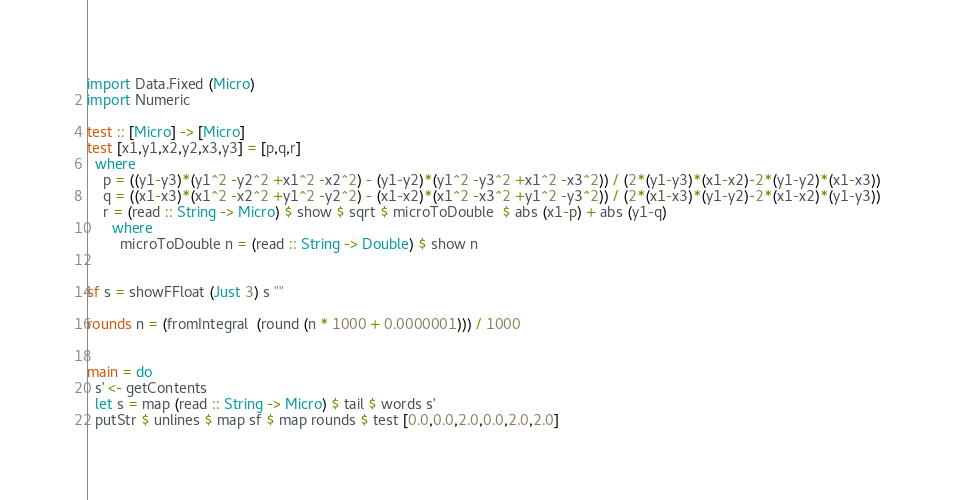<code> <loc_0><loc_0><loc_500><loc_500><_Haskell_>import Data.Fixed (Micro)
import Numeric

test :: [Micro] -> [Micro]
test [x1,y1,x2,y2,x3,y3] = [p,q,r]
  where
    p = ((y1-y3)*(y1^2 -y2^2 +x1^2 -x2^2) - (y1-y2)*(y1^2 -y3^2 +x1^2 -x3^2)) / (2*(y1-y3)*(x1-x2)-2*(y1-y2)*(x1-x3))
    q = ((x1-x3)*(x1^2 -x2^2 +y1^2 -y2^2) - (x1-x2)*(x1^2 -x3^2 +y1^2 -y3^2)) / (2*(x1-x3)*(y1-y2)-2*(x1-x2)*(y1-y3))
    r = (read :: String -> Micro) $ show $ sqrt $ microToDouble  $ abs (x1-p) + abs (y1-q)
      where
        microToDouble n = (read :: String -> Double) $ show n


sf s = showFFloat (Just 3) s ""

rounds n = (fromIntegral  (round (n * 1000 + 0.0000001))) / 1000


main = do
  s' <- getContents
  let s = map (read :: String -> Micro) $ tail $ words s'
  putStr $ unlines $ map sf $ map rounds $ test [0.0,0.0,2.0,0.0,2.0,2.0]</code> 